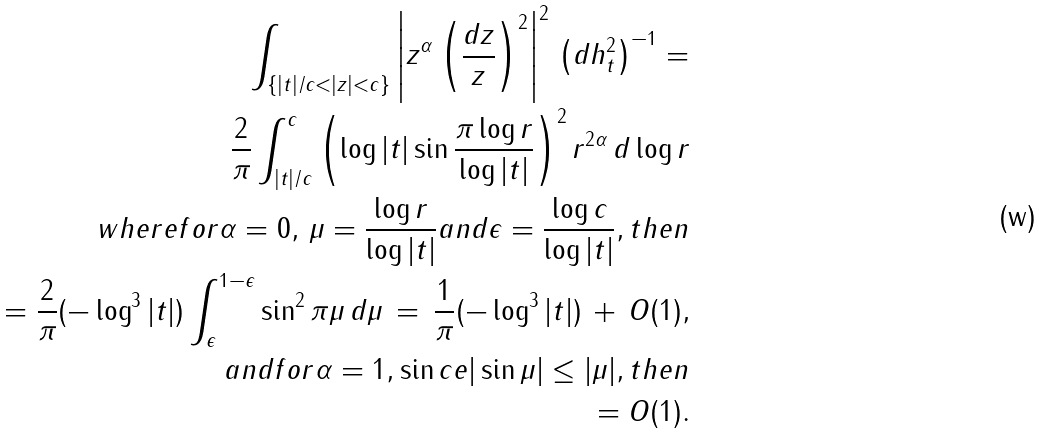Convert formula to latex. <formula><loc_0><loc_0><loc_500><loc_500>\int _ { \{ | t | / c < | z | < c \} } \left | z ^ { \alpha } \left ( \frac { d z } { z } \right ) ^ { 2 } \right | ^ { 2 } \, \left ( d h ^ { 2 } _ { t } \right ) ^ { - 1 } = \\ \frac { 2 } { \pi } \int ^ { c } _ { | t | / c } \left ( \log | t | \sin \frac { \pi \log r } { \log | t | } \right ) ^ { 2 } r ^ { 2 \alpha } \, d \log r \\ w h e r e f o r \alpha = 0 , \, \mu = \frac { \log r } { \log | t | } a n d \epsilon = \frac { \log c } { \log | t | } , t h e n \\ = \frac { 2 } { \pi } ( - \log ^ { 3 } | t | ) \int ^ { 1 - \epsilon } _ { \epsilon } \sin ^ { 2 } \pi \mu \, d \mu \, = \, \frac { 1 } { \pi } ( - \log ^ { 3 } | t | ) \, + \, O ( 1 ) , \\ a n d f o r \alpha = 1 , \sin c e | \sin \mu | \leq | \mu | , t h e n \\ = O ( 1 ) .</formula> 